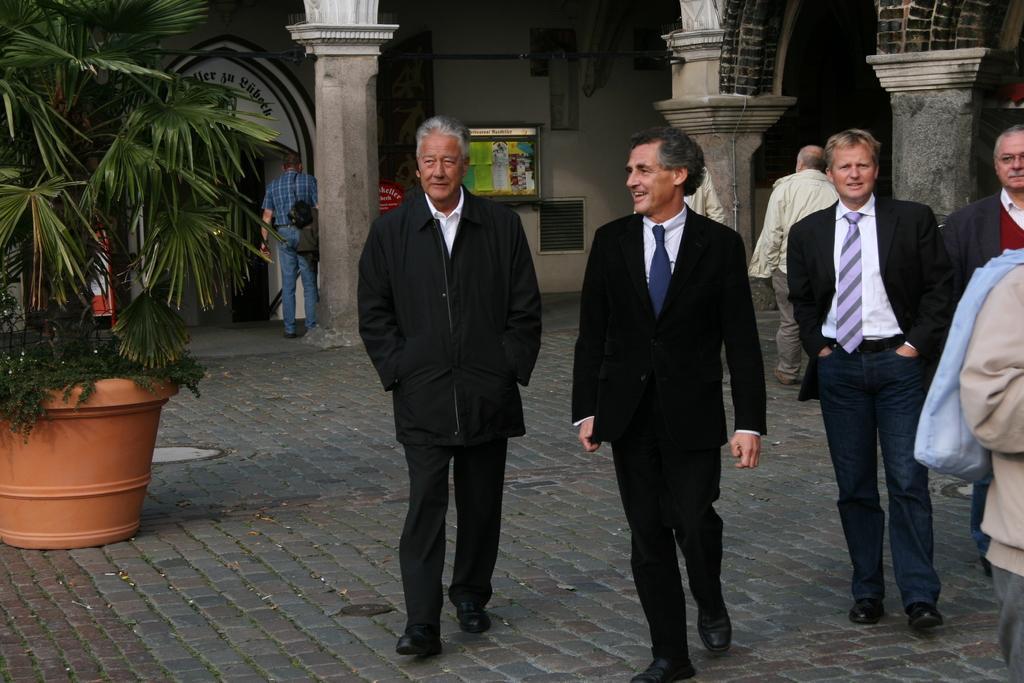Could you give a brief overview of what you see in this image? In this image, there are a few people. We can also see the ground. We can also see some plants in a pot on the left. There are a few pillars. We can also see an arch with some text. We can also see a board. We can see the wall. 